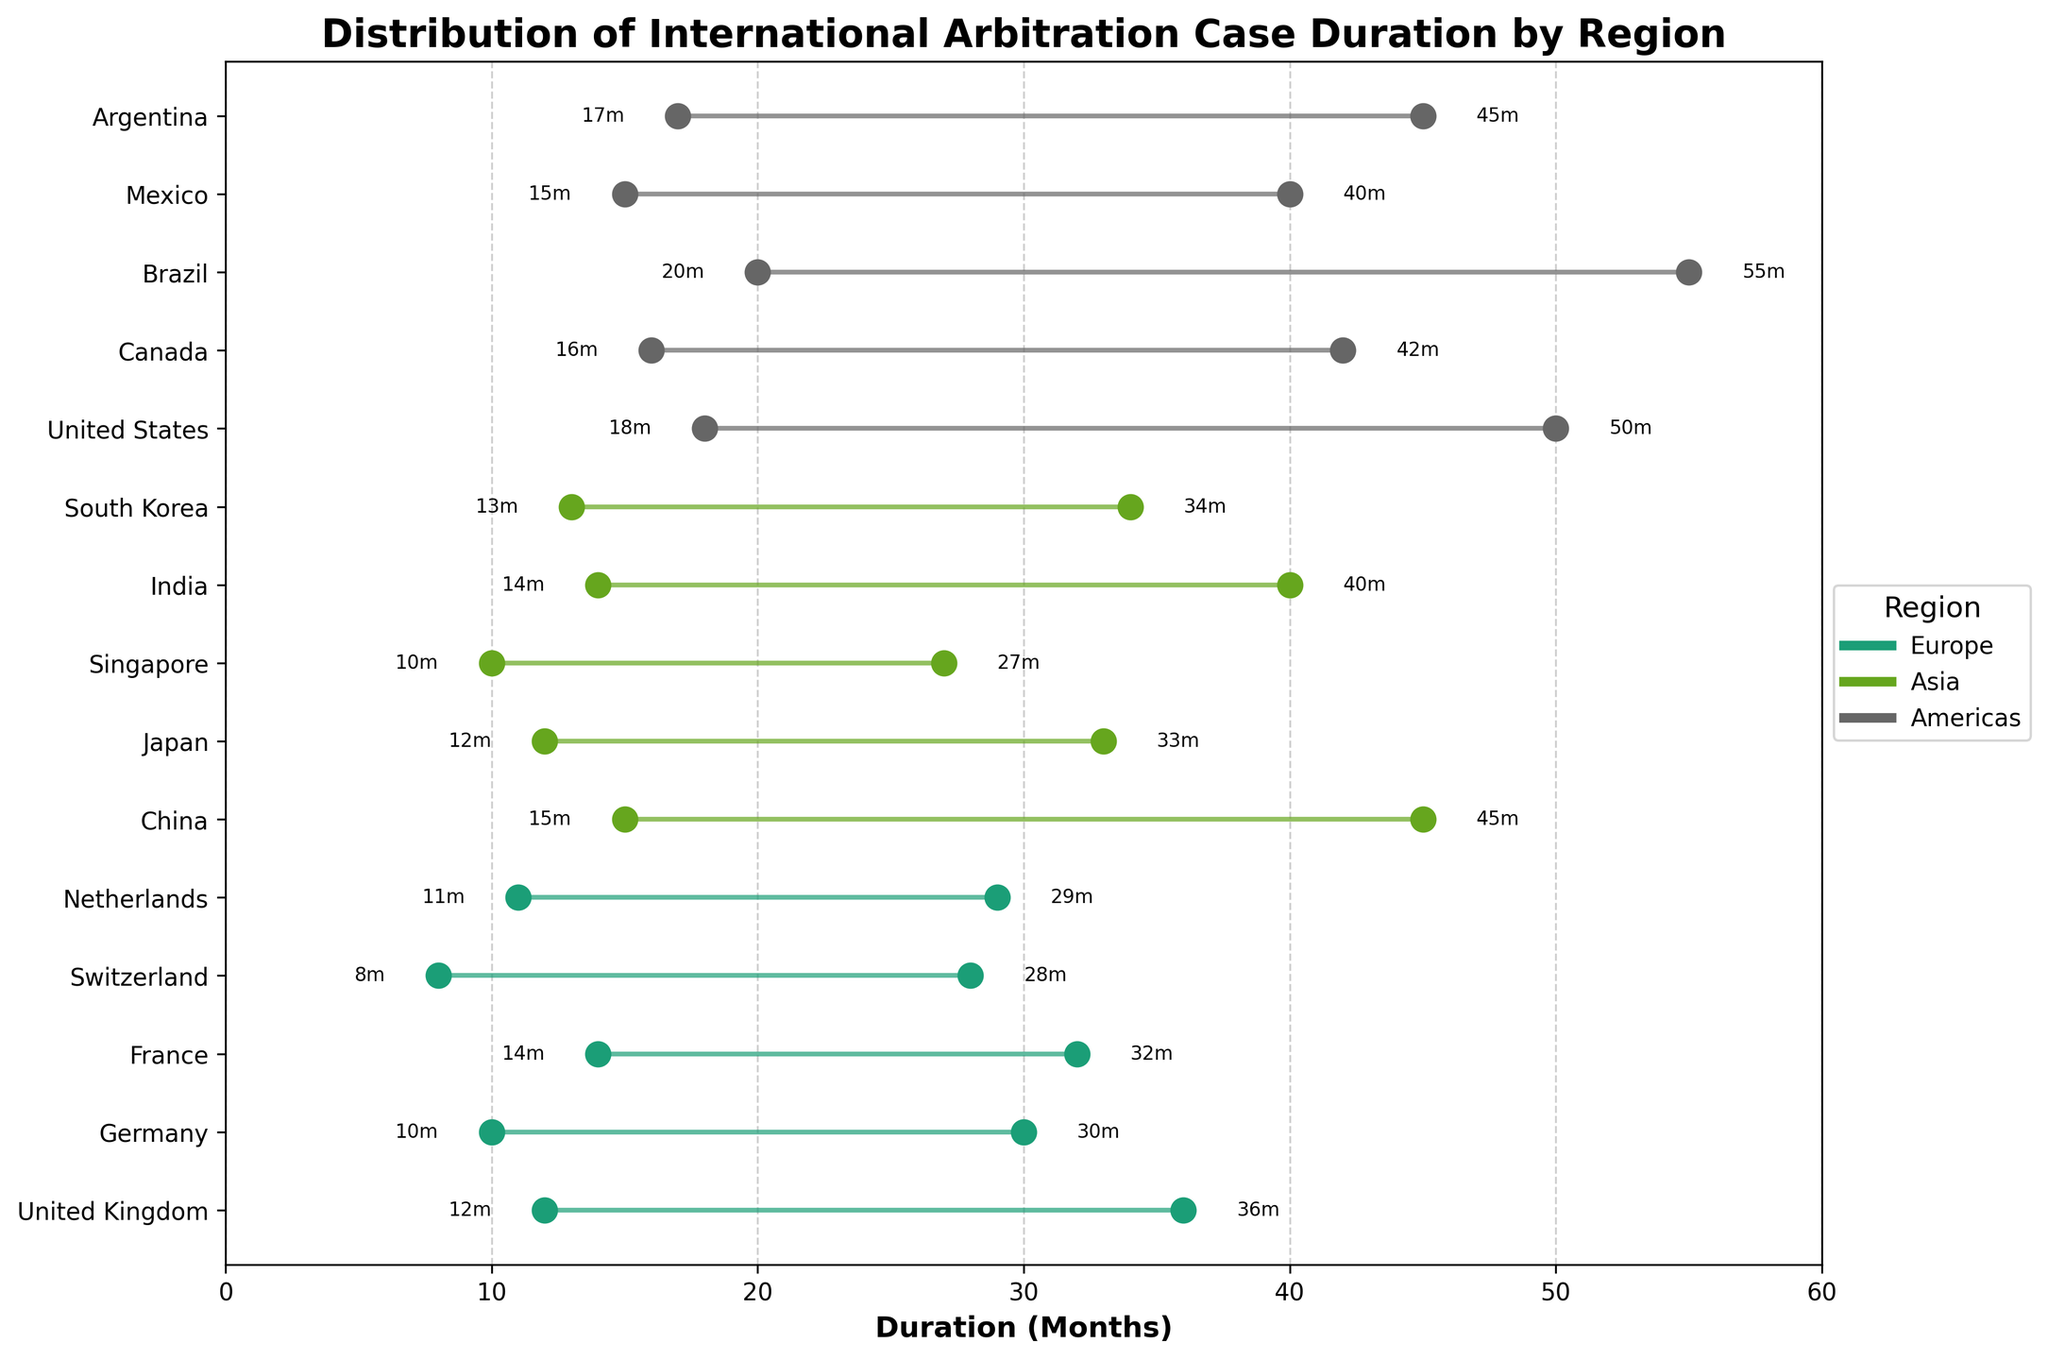Which region has the longest maximum duration for arbitration cases? By looking at the endpoints of the dumbbells, we can see that the longest maximum duration is found in the Americas, specifically in the United States with 50 months.
Answer: Americas Which country in Asia has the shortest minimum duration for arbitration cases? We identify the lowest point of the dumbbells within Asia. Singapore has the shortest minimum duration of 10 months.
Answer: Singapore How does the arbitration case duration range in Germany compare to that in Canada? Germany's range is from 10 to 30 months, while Canada's range is from 16 to 42 months. Canada has both a higher minimum and maximum duration.
Answer: Canada's range is longer and higher What is the average maximum duration of arbitration cases across European countries? Adding the maximum durations for European countries: 36 (UK) + 30 (Germany) + 32 (France) + 28 (Switzerland) + 29 (Netherlands) = 155. Dividing by the number of countries (5) yields 155/5 = 31.
Answer: 31 months Which country has the smallest range in arbitration case duration? The range is the difference between the maximum and minimum durations. Switzerland has the smallest range: 28 - 8 = 20 months, which is the smallest among all countries.
Answer: Switzerland Which region exhibits the widest variance in arbitration case durations? The Americas have significant spread; the maximum (55 in Brazil) and minimum (15 in Mexico) durations among countries vary widely.
Answer: Americas What is the median maximum duration for all countries listed? Rank the maximum durations: 27, 28, 29, 30, 32, 33, 34, 36, 40, 40, 42, 45, 45, 50, 55. The median is the middle value, which is 34 (South Korea).
Answer: 34 months How many countries from each region are displayed in the figure? Counting the labels for each region: Europe (5 countries), Asia (5 countries), and Americas (5 countries).
Answer: 5 countries per region What is the difference in minimum duration between the fastest and slowest countries? The fastest minimum is Switzerland (8 months) and the slowest minimum is Brazil (20 months). The difference is 20 - 8 = 12 months.
Answer: 12 months 